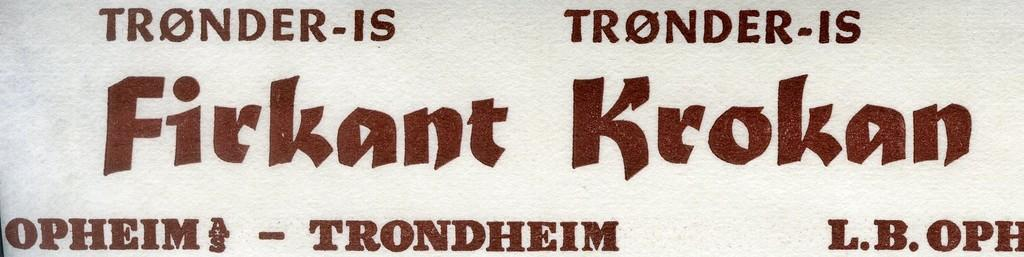<image>
Relay a brief, clear account of the picture shown. A white sign with "Firkant Krokan" in brown print. 